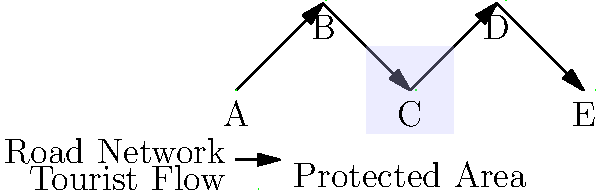Given the road network graph and protected area boundary shown above, which node is most likely to experience the highest environmental impact from increased tourism traffic, and what strategy would you recommend to mitigate this impact? To answer this question, we need to analyze the road network graph and the location of the protected area:

1. Examine the road network:
   The graph shows a linear road network with nodes A, B, C, D, and E connected sequentially.

2. Identify the protected area:
   The protected area is located between nodes B and D, encompassing node C.

3. Analyze tourist flow:
   Tourists are likely to travel from A to E, passing through all nodes.

4. Determine the most impacted node:
   Node C is most likely to experience the highest environmental impact because:
   a) It is located within the protected area.
   b) All traffic passing through the protected area must go through node C.

5. Consider mitigation strategies:
   To mitigate the environmental impact on node C, we can recommend:
   a) Implementing a traffic management system to limit the number of vehicles passing through the protected area.
   b) Developing alternative routes that bypass the protected area.
   c) Establishing strict environmental regulations for vehicles entering the protected area.
   d) Creating designated viewing areas or eco-friendly transportation options within the protected area.

6. Select the most appropriate strategy:
   Given the role of a regional planning director balancing economic benefits and environmental preservation, the most appropriate strategy would be to implement a traffic management system. This approach allows for continued tourism while minimizing environmental impact.
Answer: Node C; implement a traffic management system 